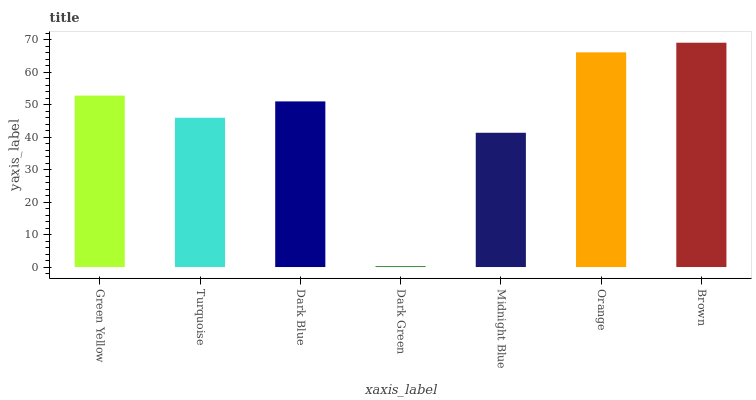Is Dark Green the minimum?
Answer yes or no. Yes. Is Brown the maximum?
Answer yes or no. Yes. Is Turquoise the minimum?
Answer yes or no. No. Is Turquoise the maximum?
Answer yes or no. No. Is Green Yellow greater than Turquoise?
Answer yes or no. Yes. Is Turquoise less than Green Yellow?
Answer yes or no. Yes. Is Turquoise greater than Green Yellow?
Answer yes or no. No. Is Green Yellow less than Turquoise?
Answer yes or no. No. Is Dark Blue the high median?
Answer yes or no. Yes. Is Dark Blue the low median?
Answer yes or no. Yes. Is Green Yellow the high median?
Answer yes or no. No. Is Midnight Blue the low median?
Answer yes or no. No. 